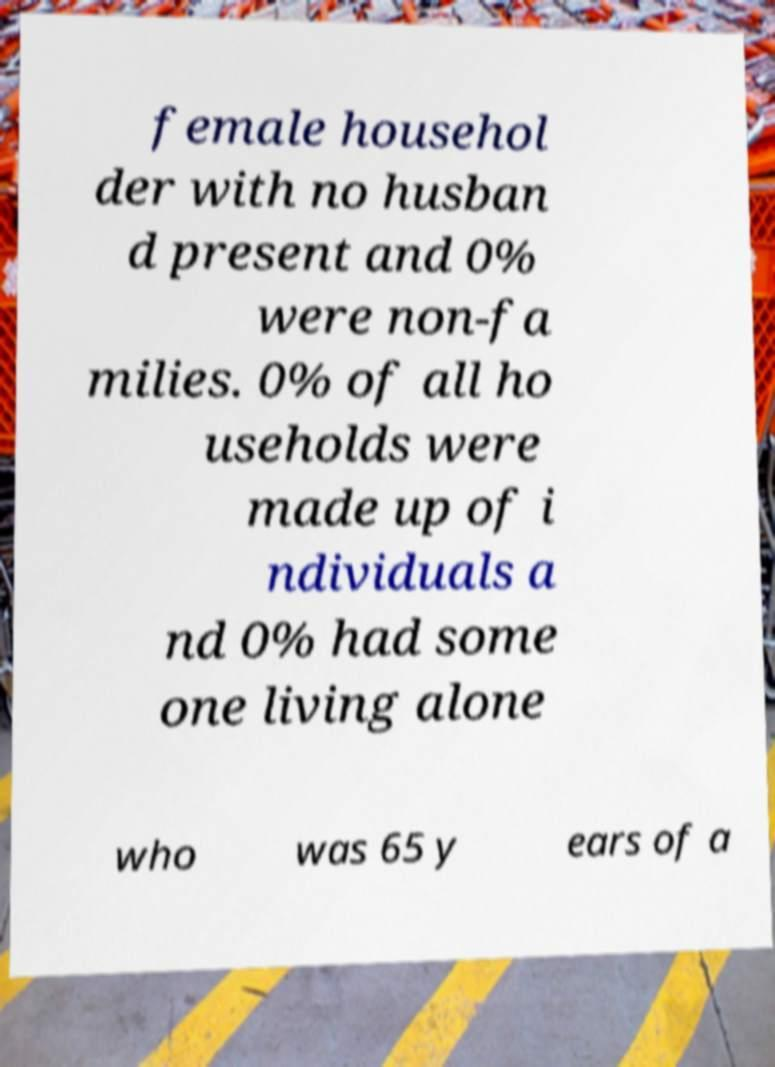There's text embedded in this image that I need extracted. Can you transcribe it verbatim? female househol der with no husban d present and 0% were non-fa milies. 0% of all ho useholds were made up of i ndividuals a nd 0% had some one living alone who was 65 y ears of a 